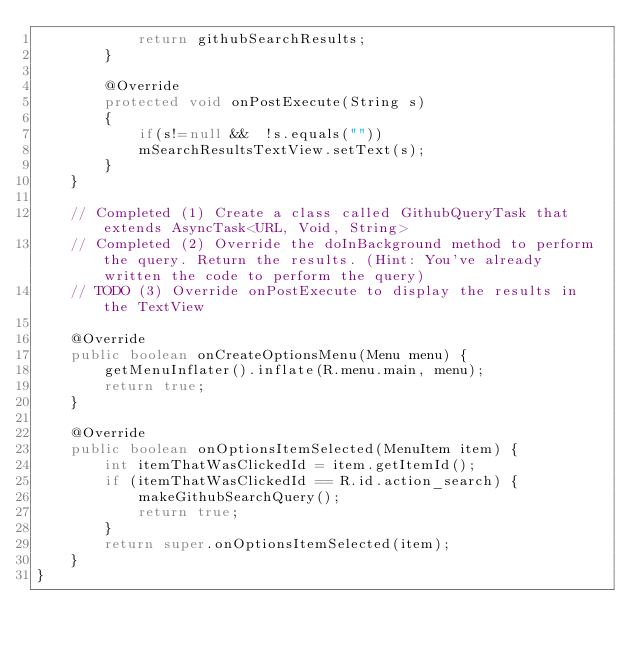<code> <loc_0><loc_0><loc_500><loc_500><_Java_>            return githubSearchResults;
        }

        @Override
        protected void onPostExecute(String s)
        {
            if(s!=null &&  !s.equals(""))
            mSearchResultsTextView.setText(s);
        }
    }

    // Completed (1) Create a class called GithubQueryTask that extends AsyncTask<URL, Void, String>
    // Completed (2) Override the doInBackground method to perform the query. Return the results. (Hint: You've already written the code to perform the query)
    // TODO (3) Override onPostExecute to display the results in the TextView

    @Override
    public boolean onCreateOptionsMenu(Menu menu) {
        getMenuInflater().inflate(R.menu.main, menu);
        return true;
    }

    @Override
    public boolean onOptionsItemSelected(MenuItem item) {
        int itemThatWasClickedId = item.getItemId();
        if (itemThatWasClickedId == R.id.action_search) {
            makeGithubSearchQuery();
            return true;
        }
        return super.onOptionsItemSelected(item);
    }
}
</code> 